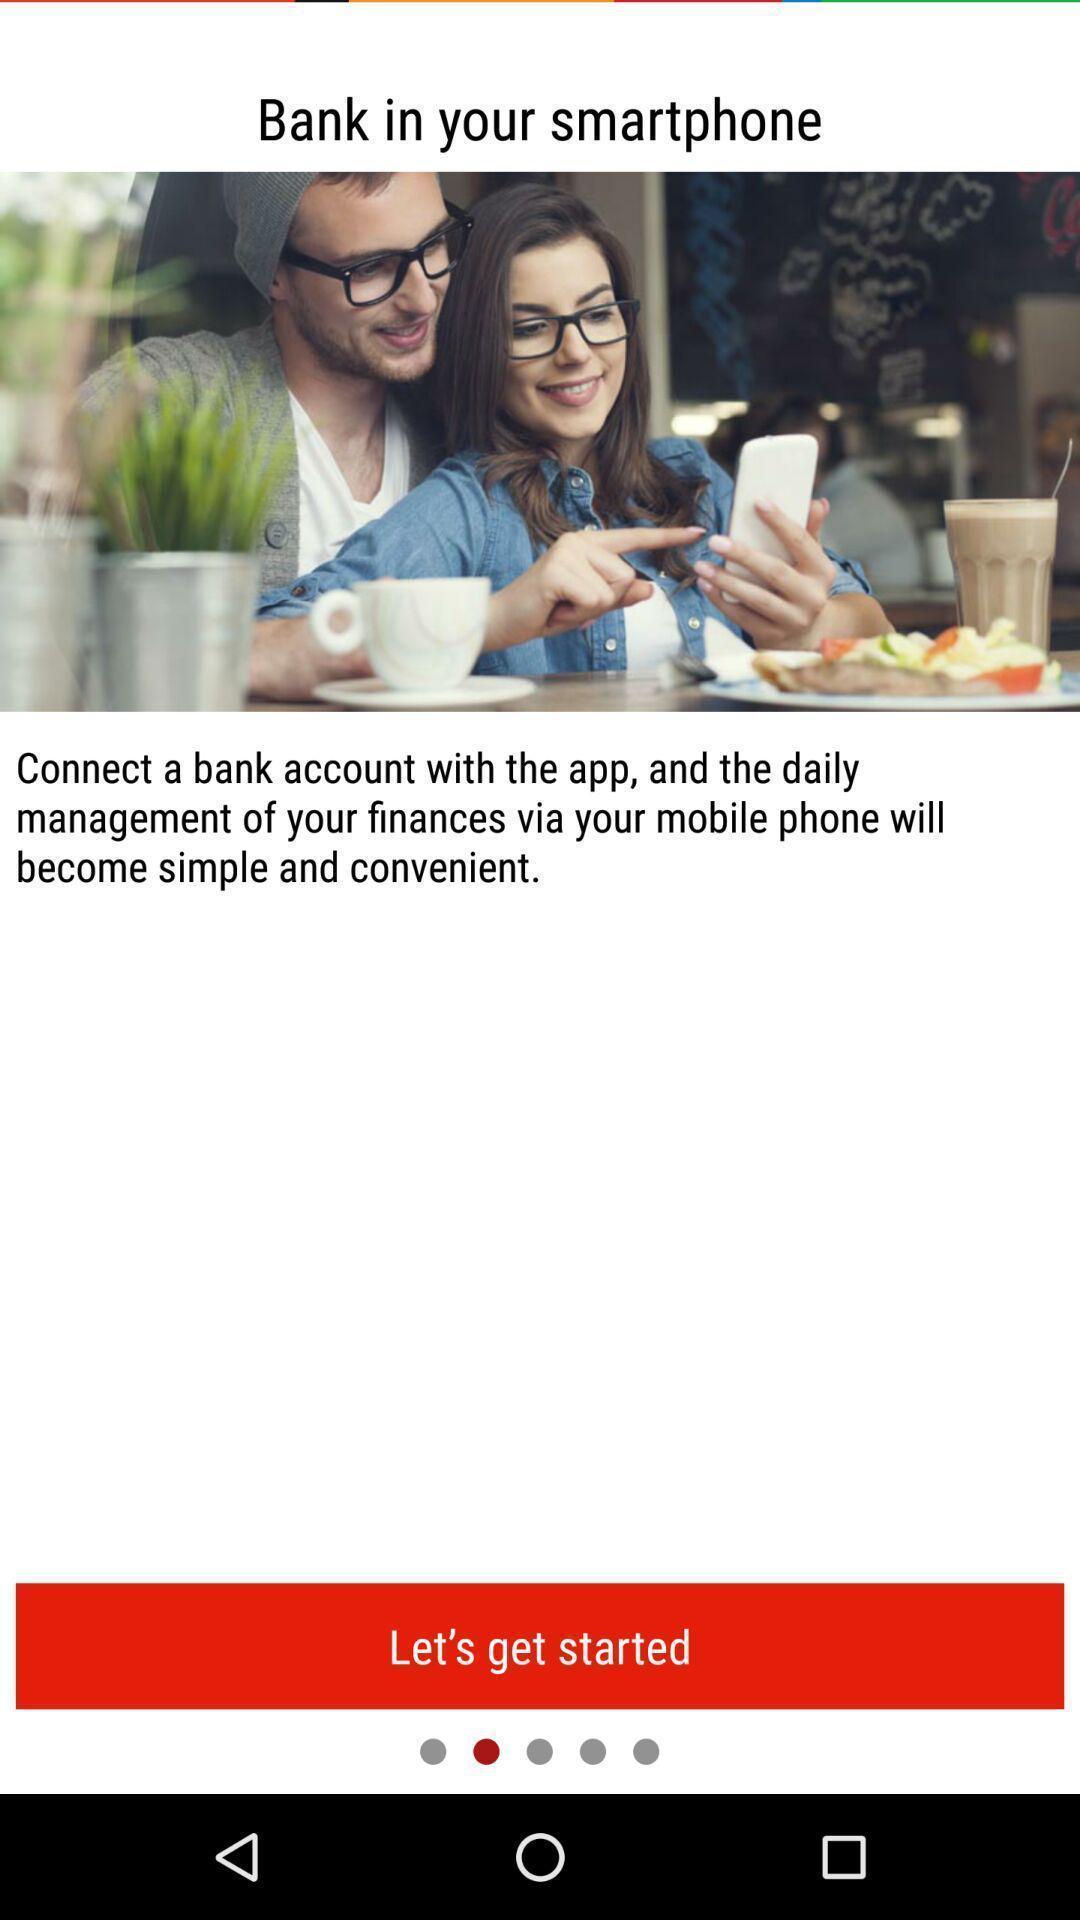Describe the key features of this screenshot. Welcome page of a banking app. 